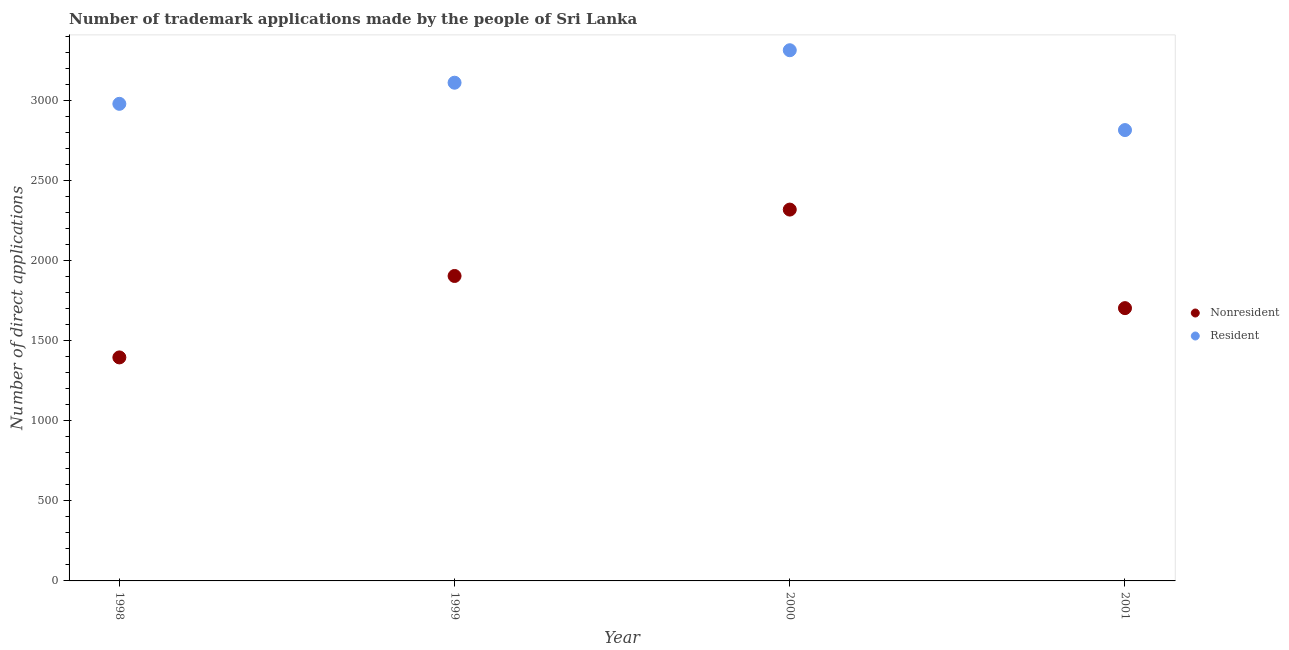How many different coloured dotlines are there?
Provide a succinct answer. 2. What is the number of trademark applications made by residents in 1998?
Your response must be concise. 2982. Across all years, what is the maximum number of trademark applications made by residents?
Your response must be concise. 3317. Across all years, what is the minimum number of trademark applications made by residents?
Your answer should be compact. 2818. In which year was the number of trademark applications made by residents maximum?
Make the answer very short. 2000. What is the total number of trademark applications made by residents in the graph?
Offer a terse response. 1.22e+04. What is the difference between the number of trademark applications made by residents in 1999 and that in 2000?
Offer a very short reply. -203. What is the difference between the number of trademark applications made by residents in 2001 and the number of trademark applications made by non residents in 1999?
Give a very brief answer. 912. What is the average number of trademark applications made by non residents per year?
Offer a very short reply. 1832.25. In the year 1999, what is the difference between the number of trademark applications made by non residents and number of trademark applications made by residents?
Your response must be concise. -1208. In how many years, is the number of trademark applications made by non residents greater than 3000?
Give a very brief answer. 0. What is the ratio of the number of trademark applications made by non residents in 1998 to that in 2000?
Offer a terse response. 0.6. Is the number of trademark applications made by non residents in 1999 less than that in 2001?
Your answer should be compact. No. Is the difference between the number of trademark applications made by non residents in 1998 and 1999 greater than the difference between the number of trademark applications made by residents in 1998 and 1999?
Offer a very short reply. No. What is the difference between the highest and the second highest number of trademark applications made by residents?
Ensure brevity in your answer.  203. What is the difference between the highest and the lowest number of trademark applications made by residents?
Offer a terse response. 499. In how many years, is the number of trademark applications made by residents greater than the average number of trademark applications made by residents taken over all years?
Your response must be concise. 2. Is the number of trademark applications made by non residents strictly greater than the number of trademark applications made by residents over the years?
Your answer should be compact. No. How many dotlines are there?
Your answer should be compact. 2. How many years are there in the graph?
Keep it short and to the point. 4. Are the values on the major ticks of Y-axis written in scientific E-notation?
Make the answer very short. No. How many legend labels are there?
Offer a terse response. 2. What is the title of the graph?
Provide a succinct answer. Number of trademark applications made by the people of Sri Lanka. What is the label or title of the Y-axis?
Keep it short and to the point. Number of direct applications. What is the Number of direct applications in Nonresident in 1998?
Your answer should be very brief. 1397. What is the Number of direct applications of Resident in 1998?
Give a very brief answer. 2982. What is the Number of direct applications in Nonresident in 1999?
Offer a terse response. 1906. What is the Number of direct applications in Resident in 1999?
Your response must be concise. 3114. What is the Number of direct applications in Nonresident in 2000?
Make the answer very short. 2321. What is the Number of direct applications of Resident in 2000?
Give a very brief answer. 3317. What is the Number of direct applications in Nonresident in 2001?
Give a very brief answer. 1705. What is the Number of direct applications in Resident in 2001?
Provide a succinct answer. 2818. Across all years, what is the maximum Number of direct applications in Nonresident?
Keep it short and to the point. 2321. Across all years, what is the maximum Number of direct applications in Resident?
Provide a succinct answer. 3317. Across all years, what is the minimum Number of direct applications in Nonresident?
Provide a succinct answer. 1397. Across all years, what is the minimum Number of direct applications of Resident?
Ensure brevity in your answer.  2818. What is the total Number of direct applications of Nonresident in the graph?
Ensure brevity in your answer.  7329. What is the total Number of direct applications of Resident in the graph?
Give a very brief answer. 1.22e+04. What is the difference between the Number of direct applications of Nonresident in 1998 and that in 1999?
Provide a succinct answer. -509. What is the difference between the Number of direct applications in Resident in 1998 and that in 1999?
Offer a terse response. -132. What is the difference between the Number of direct applications of Nonresident in 1998 and that in 2000?
Provide a short and direct response. -924. What is the difference between the Number of direct applications of Resident in 1998 and that in 2000?
Ensure brevity in your answer.  -335. What is the difference between the Number of direct applications in Nonresident in 1998 and that in 2001?
Make the answer very short. -308. What is the difference between the Number of direct applications of Resident in 1998 and that in 2001?
Offer a terse response. 164. What is the difference between the Number of direct applications in Nonresident in 1999 and that in 2000?
Keep it short and to the point. -415. What is the difference between the Number of direct applications in Resident in 1999 and that in 2000?
Ensure brevity in your answer.  -203. What is the difference between the Number of direct applications in Nonresident in 1999 and that in 2001?
Make the answer very short. 201. What is the difference between the Number of direct applications in Resident in 1999 and that in 2001?
Provide a succinct answer. 296. What is the difference between the Number of direct applications in Nonresident in 2000 and that in 2001?
Provide a succinct answer. 616. What is the difference between the Number of direct applications of Resident in 2000 and that in 2001?
Your answer should be compact. 499. What is the difference between the Number of direct applications of Nonresident in 1998 and the Number of direct applications of Resident in 1999?
Provide a succinct answer. -1717. What is the difference between the Number of direct applications in Nonresident in 1998 and the Number of direct applications in Resident in 2000?
Ensure brevity in your answer.  -1920. What is the difference between the Number of direct applications of Nonresident in 1998 and the Number of direct applications of Resident in 2001?
Provide a short and direct response. -1421. What is the difference between the Number of direct applications of Nonresident in 1999 and the Number of direct applications of Resident in 2000?
Offer a terse response. -1411. What is the difference between the Number of direct applications of Nonresident in 1999 and the Number of direct applications of Resident in 2001?
Your response must be concise. -912. What is the difference between the Number of direct applications of Nonresident in 2000 and the Number of direct applications of Resident in 2001?
Ensure brevity in your answer.  -497. What is the average Number of direct applications in Nonresident per year?
Your answer should be very brief. 1832.25. What is the average Number of direct applications of Resident per year?
Your answer should be very brief. 3057.75. In the year 1998, what is the difference between the Number of direct applications in Nonresident and Number of direct applications in Resident?
Your response must be concise. -1585. In the year 1999, what is the difference between the Number of direct applications in Nonresident and Number of direct applications in Resident?
Offer a terse response. -1208. In the year 2000, what is the difference between the Number of direct applications of Nonresident and Number of direct applications of Resident?
Offer a terse response. -996. In the year 2001, what is the difference between the Number of direct applications of Nonresident and Number of direct applications of Resident?
Make the answer very short. -1113. What is the ratio of the Number of direct applications in Nonresident in 1998 to that in 1999?
Offer a terse response. 0.73. What is the ratio of the Number of direct applications of Resident in 1998 to that in 1999?
Offer a very short reply. 0.96. What is the ratio of the Number of direct applications of Nonresident in 1998 to that in 2000?
Make the answer very short. 0.6. What is the ratio of the Number of direct applications in Resident in 1998 to that in 2000?
Your answer should be very brief. 0.9. What is the ratio of the Number of direct applications of Nonresident in 1998 to that in 2001?
Provide a short and direct response. 0.82. What is the ratio of the Number of direct applications in Resident in 1998 to that in 2001?
Make the answer very short. 1.06. What is the ratio of the Number of direct applications of Nonresident in 1999 to that in 2000?
Make the answer very short. 0.82. What is the ratio of the Number of direct applications of Resident in 1999 to that in 2000?
Keep it short and to the point. 0.94. What is the ratio of the Number of direct applications in Nonresident in 1999 to that in 2001?
Give a very brief answer. 1.12. What is the ratio of the Number of direct applications in Resident in 1999 to that in 2001?
Ensure brevity in your answer.  1.1. What is the ratio of the Number of direct applications of Nonresident in 2000 to that in 2001?
Keep it short and to the point. 1.36. What is the ratio of the Number of direct applications in Resident in 2000 to that in 2001?
Your answer should be compact. 1.18. What is the difference between the highest and the second highest Number of direct applications of Nonresident?
Your response must be concise. 415. What is the difference between the highest and the second highest Number of direct applications of Resident?
Offer a terse response. 203. What is the difference between the highest and the lowest Number of direct applications in Nonresident?
Your answer should be very brief. 924. What is the difference between the highest and the lowest Number of direct applications in Resident?
Your answer should be compact. 499. 